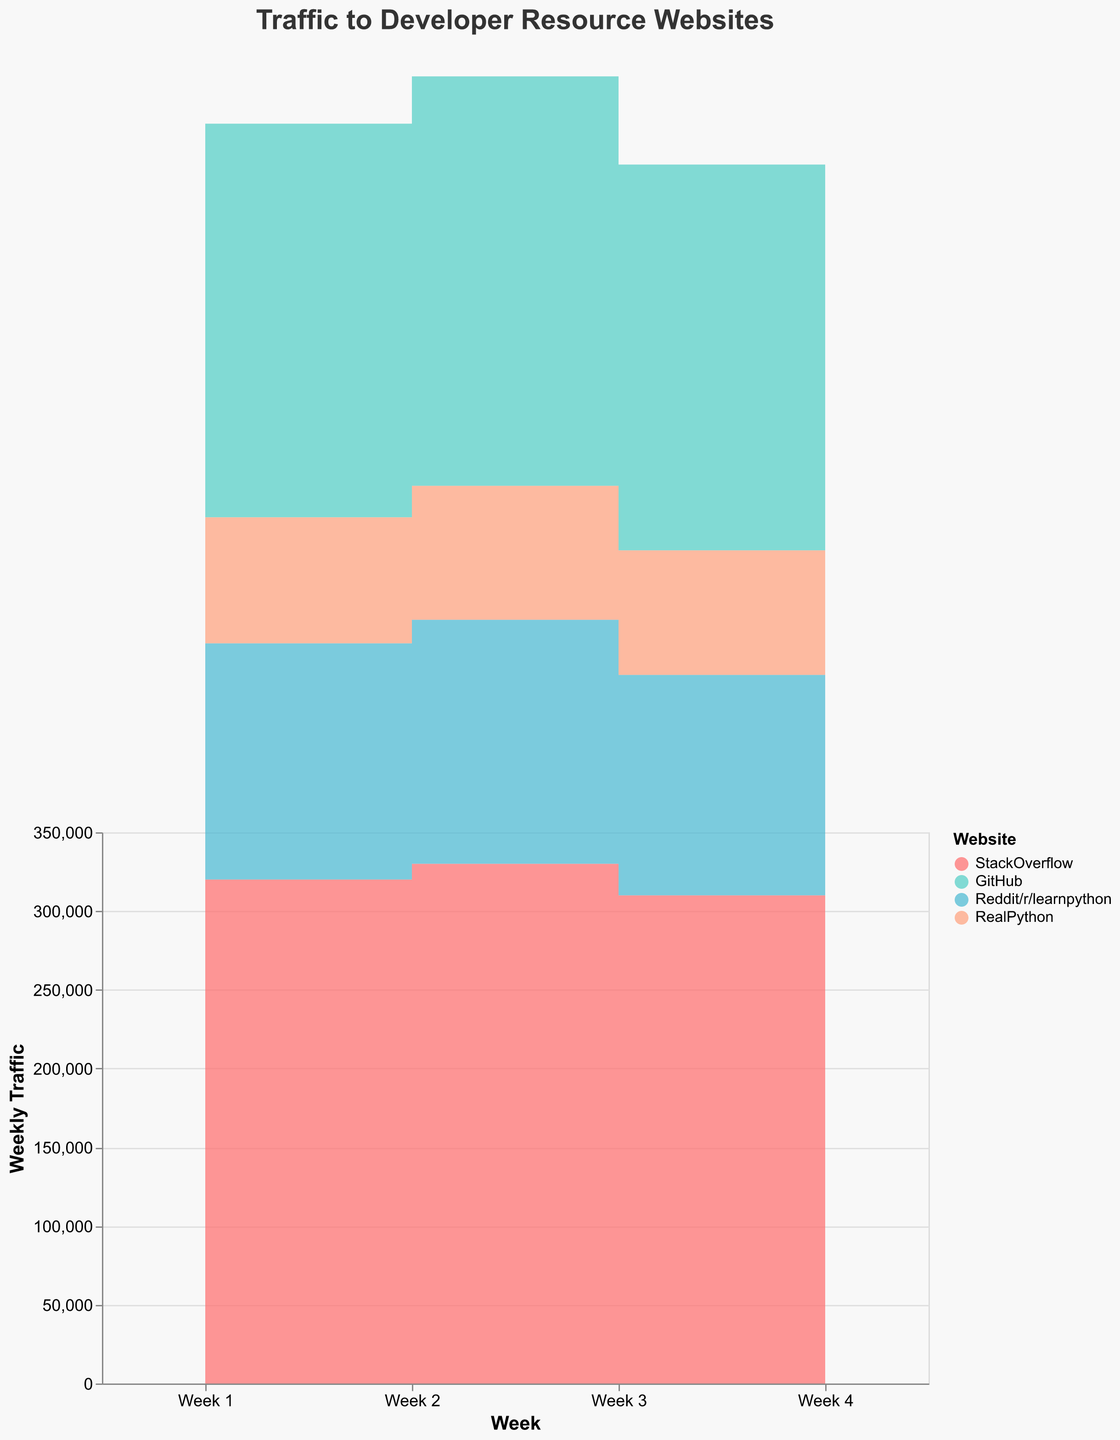Which website has the highest traffic in Week 4? Look at the traffic values for Week 4 across all websites. The traffic for StackOverflow is 335,000, which is the highest among the websites listed.
Answer: StackOverflow When does RealPython have its lowest traffic? Look through the weekly traffic values of RealPython. Its lowest traffic is 79,000, which occurs in Week 3.
Answer: Week 3 What is the trend of traffic for GitHub over the four weeks? Observe the traffic changes for GitHub from Week 1 to Week 4. The values are 250,000, 260,000, 245,000, and 270,000, respectively, indicating a fluctuating but overall increasing trend.
Answer: Increasing trend with fluctuations Which website shows the most consistent week-to-week traffic? Compare the week-to-week variances in traffic for each website. RealPython has the smallest changes in traffic values (80,000 to 88,000), showing the most consistency.
Answer: RealPython By how much does traffic for StackOverflow increase from Week 3 to Week 4? The traffic for StackOverflow in Week 3 is 310,000 and in Week 4 is 335,000. The increase is 335,000 - 310,000 = 25,000.
Answer: 25,000 Which two websites have the least and the most traffic in Week 2? In Week 2, RealPython has the least traffic with 85,000, while StackOverflow has the most traffic with 330,000.
Answer: RealPython and StackOverflow How does the traffic for Reddit/r/learnpython change over the four weeks? Observe the traffic values for Reddit/r/learnpython: 150,000, 155,000, 140,000, and 160,000. The pattern shows slight fluctuation with an overall increase by Week 4.
Answer: Slight fluctuation with an increasing trend What is the average traffic for GitHub over the four weeks? Calculate the average traffic for GitHub by adding its weekly traffic values and dividing by 4: (250,000 + 260,000 + 245,000 + 270,000) / 4 = 256,250.
Answer: 256,250 Which website's traffic increases the most between Week 1 and Week 4? Calculate the difference in traffic from Week 1 to Week 4 for each website: StackOverflow (15,000), GitHub (20,000), Reddit/r/learnpython (10,000), and RealPython (8,000). GitHub has the largest increase of 20,000.
Answer: GitHub 